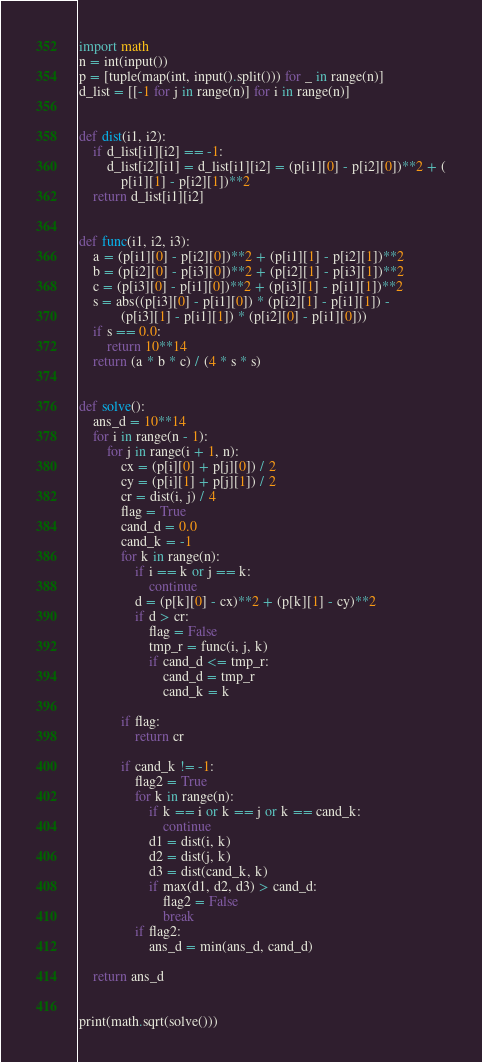Convert code to text. <code><loc_0><loc_0><loc_500><loc_500><_Python_>import math
n = int(input())
p = [tuple(map(int, input().split())) for _ in range(n)]
d_list = [[-1 for j in range(n)] for i in range(n)]


def dist(i1, i2):
    if d_list[i1][i2] == -1:
        d_list[i2][i1] = d_list[i1][i2] = (p[i1][0] - p[i2][0])**2 + (
            p[i1][1] - p[i2][1])**2
    return d_list[i1][i2]


def func(i1, i2, i3):
    a = (p[i1][0] - p[i2][0])**2 + (p[i1][1] - p[i2][1])**2
    b = (p[i2][0] - p[i3][0])**2 + (p[i2][1] - p[i3][1])**2
    c = (p[i3][0] - p[i1][0])**2 + (p[i3][1] - p[i1][1])**2
    s = abs((p[i3][0] - p[i1][0]) * (p[i2][1] - p[i1][1]) -
            (p[i3][1] - p[i1][1]) * (p[i2][0] - p[i1][0]))
    if s == 0.0:
        return 10**14
    return (a * b * c) / (4 * s * s)


def solve():
    ans_d = 10**14
    for i in range(n - 1):
        for j in range(i + 1, n):
            cx = (p[i][0] + p[j][0]) / 2
            cy = (p[i][1] + p[j][1]) / 2
            cr = dist(i, j) / 4
            flag = True
            cand_d = 0.0
            cand_k = -1
            for k in range(n):
                if i == k or j == k:
                    continue
                d = (p[k][0] - cx)**2 + (p[k][1] - cy)**2
                if d > cr:
                    flag = False
                    tmp_r = func(i, j, k)
                    if cand_d <= tmp_r:
                        cand_d = tmp_r
                        cand_k = k

            if flag:
                return cr

            if cand_k != -1:
                flag2 = True
                for k in range(n):
                    if k == i or k == j or k == cand_k:
                        continue
                    d1 = dist(i, k)
                    d2 = dist(j, k)
                    d3 = dist(cand_k, k)
                    if max(d1, d2, d3) > cand_d:
                        flag2 = False
                        break
                if flag2:
                    ans_d = min(ans_d, cand_d)

    return ans_d


print(math.sqrt(solve()))
</code> 